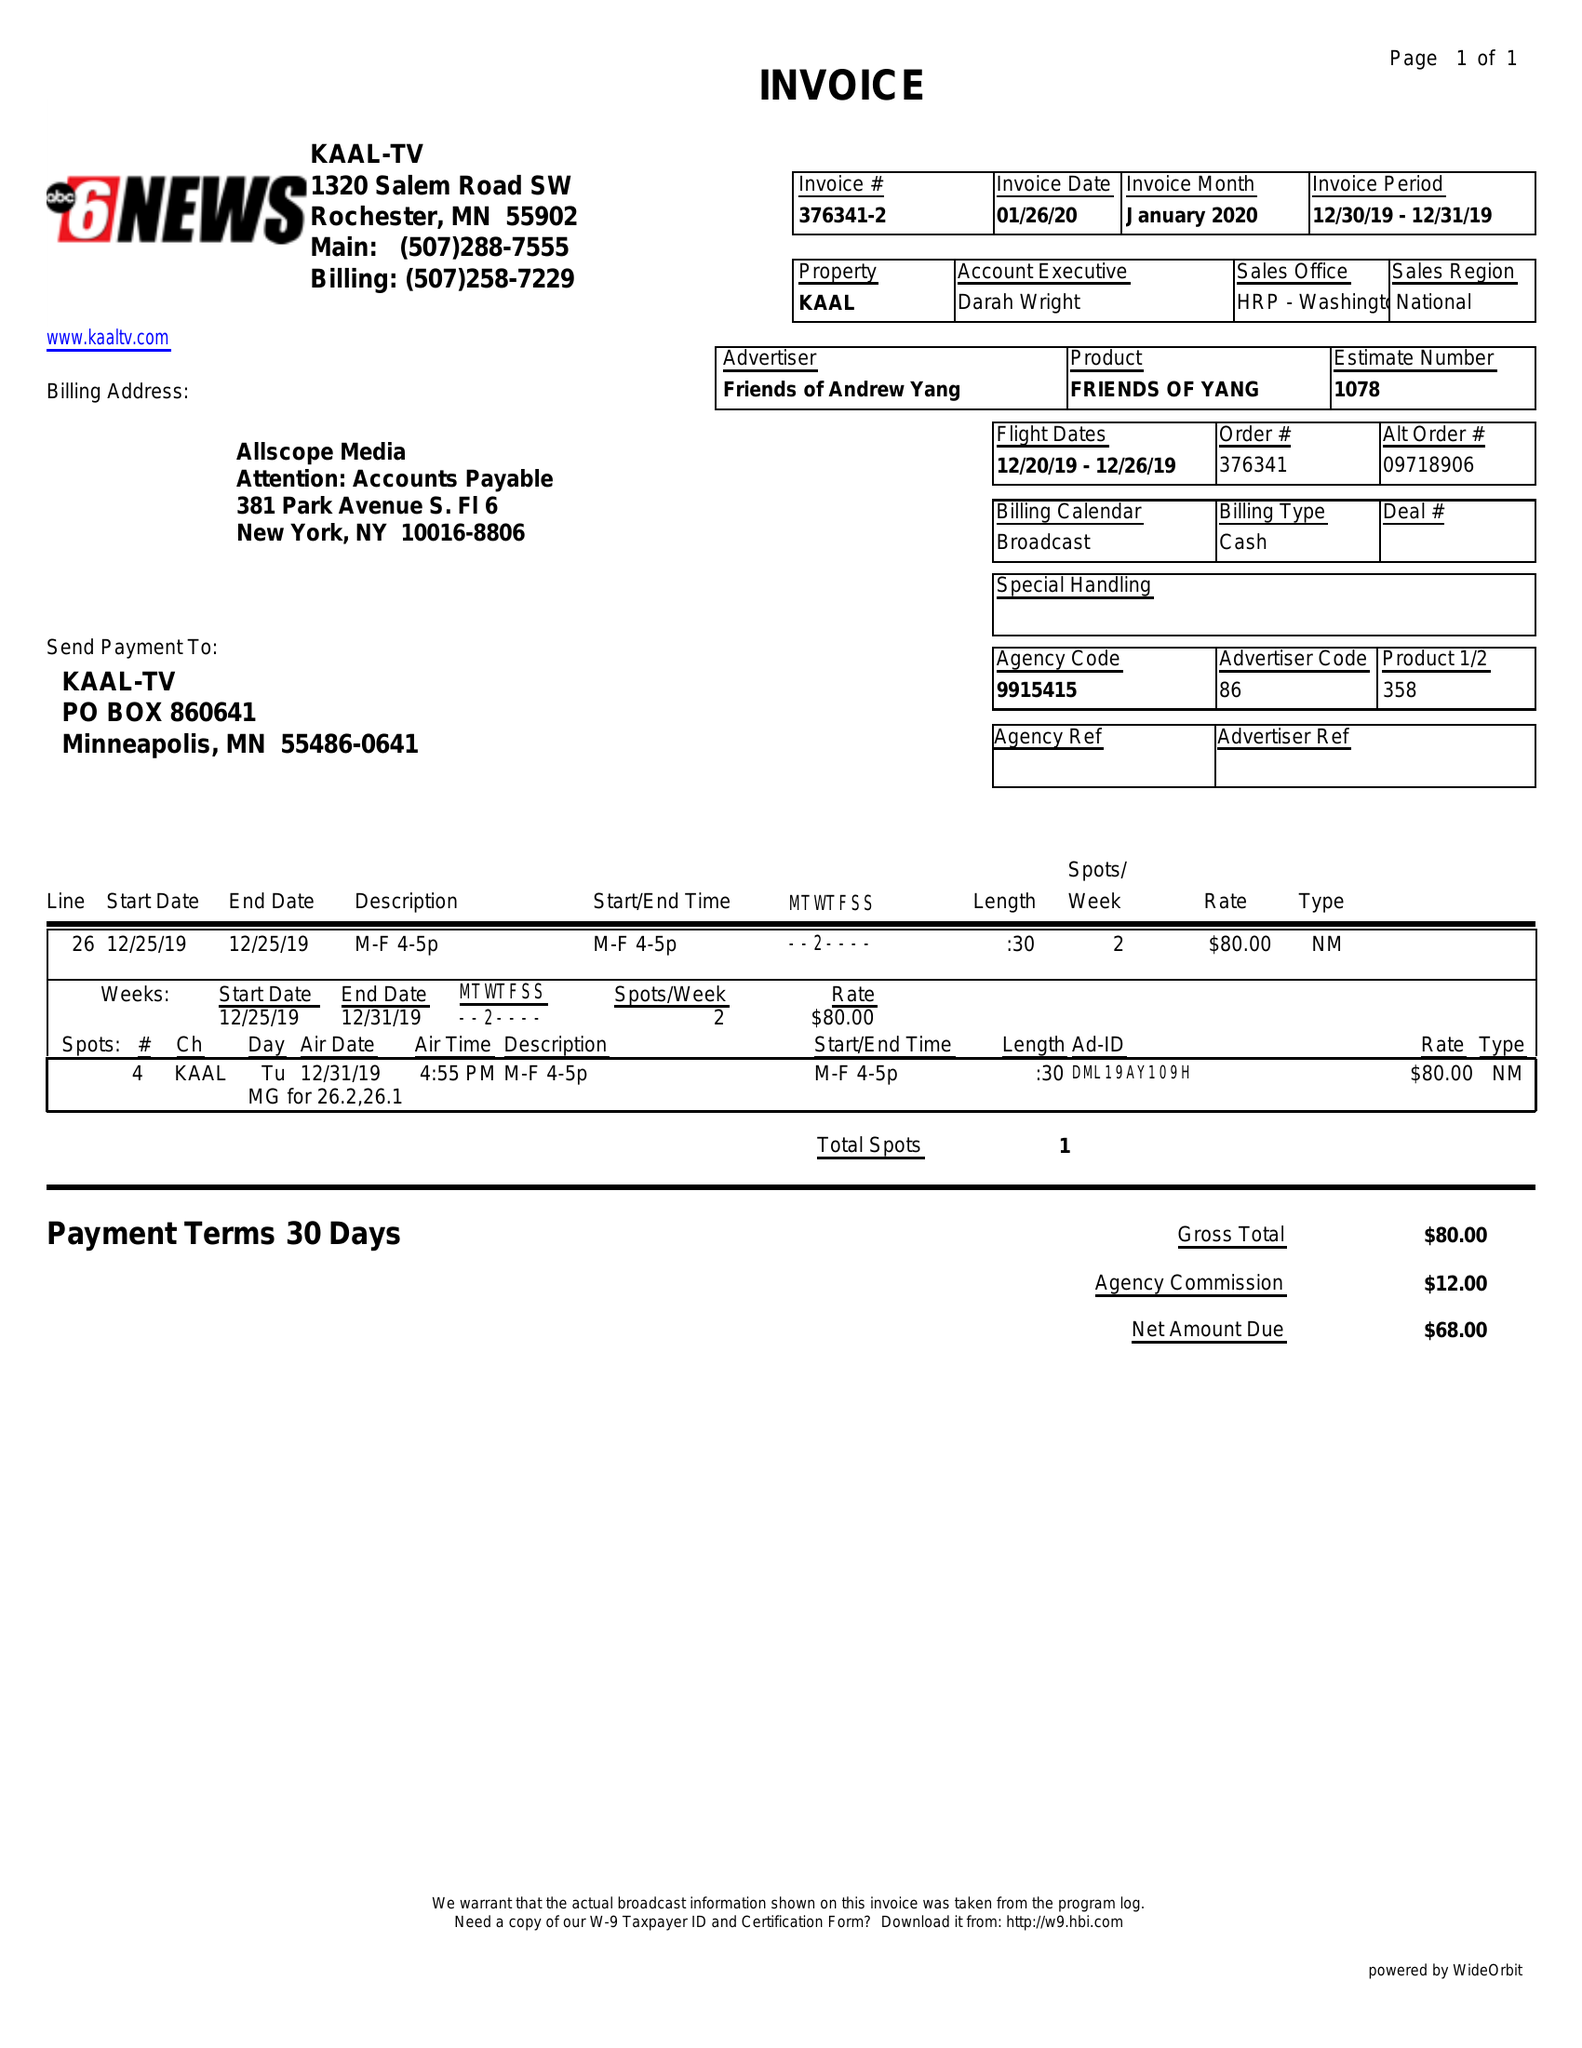What is the value for the contract_num?
Answer the question using a single word or phrase. 376341 